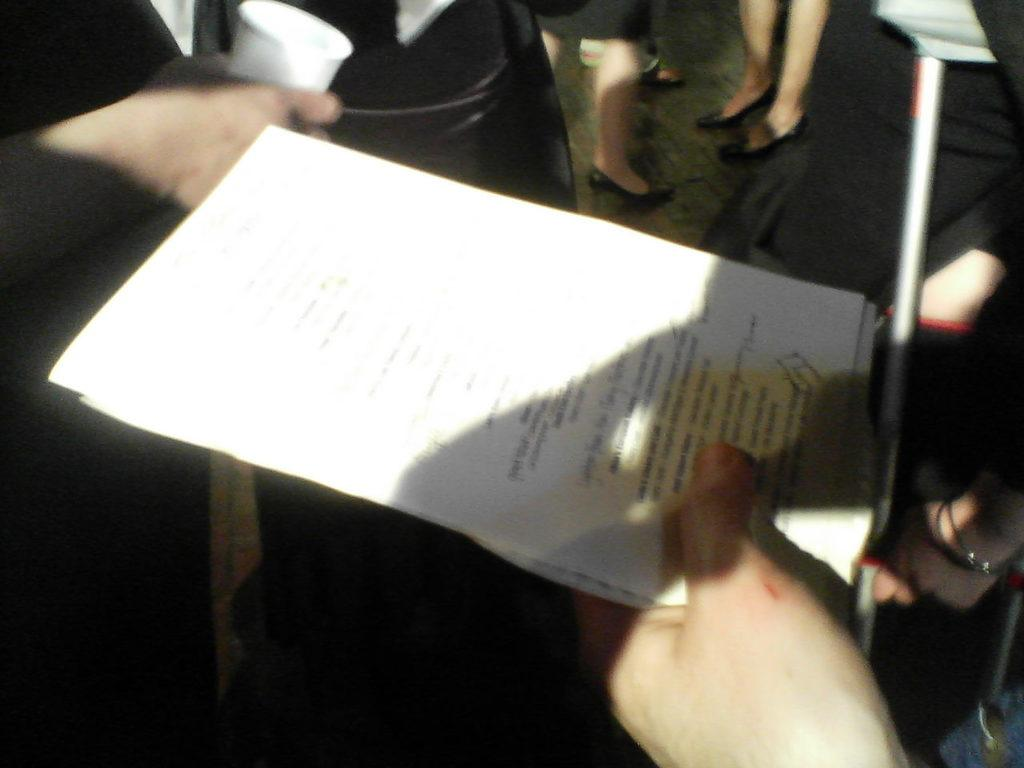What are the people in the foreground of the image holding? The people in the foreground of the image are holding text papers. Can you describe the people in the background of the image? There are people standing in the background of the image. What is the person on the left side of the image holding? The person on the left side of the image is holding a cup. What type of hat is the person wearing in the image? There is no hat visible in the image; the people are holding text papers and standing in the background. 